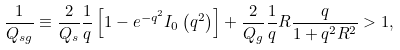<formula> <loc_0><loc_0><loc_500><loc_500>\frac { 1 } { Q _ { s g } } \equiv \frac { 2 } { Q _ { s } } \frac { 1 } { q } \left [ 1 - e ^ { - q ^ { 2 } } I _ { 0 } \left ( q ^ { 2 } \right ) \right ] + \frac { 2 } { Q _ { g } } \frac { 1 } { q } R \frac { q } { 1 + q ^ { 2 } R ^ { 2 } } > 1 ,</formula> 